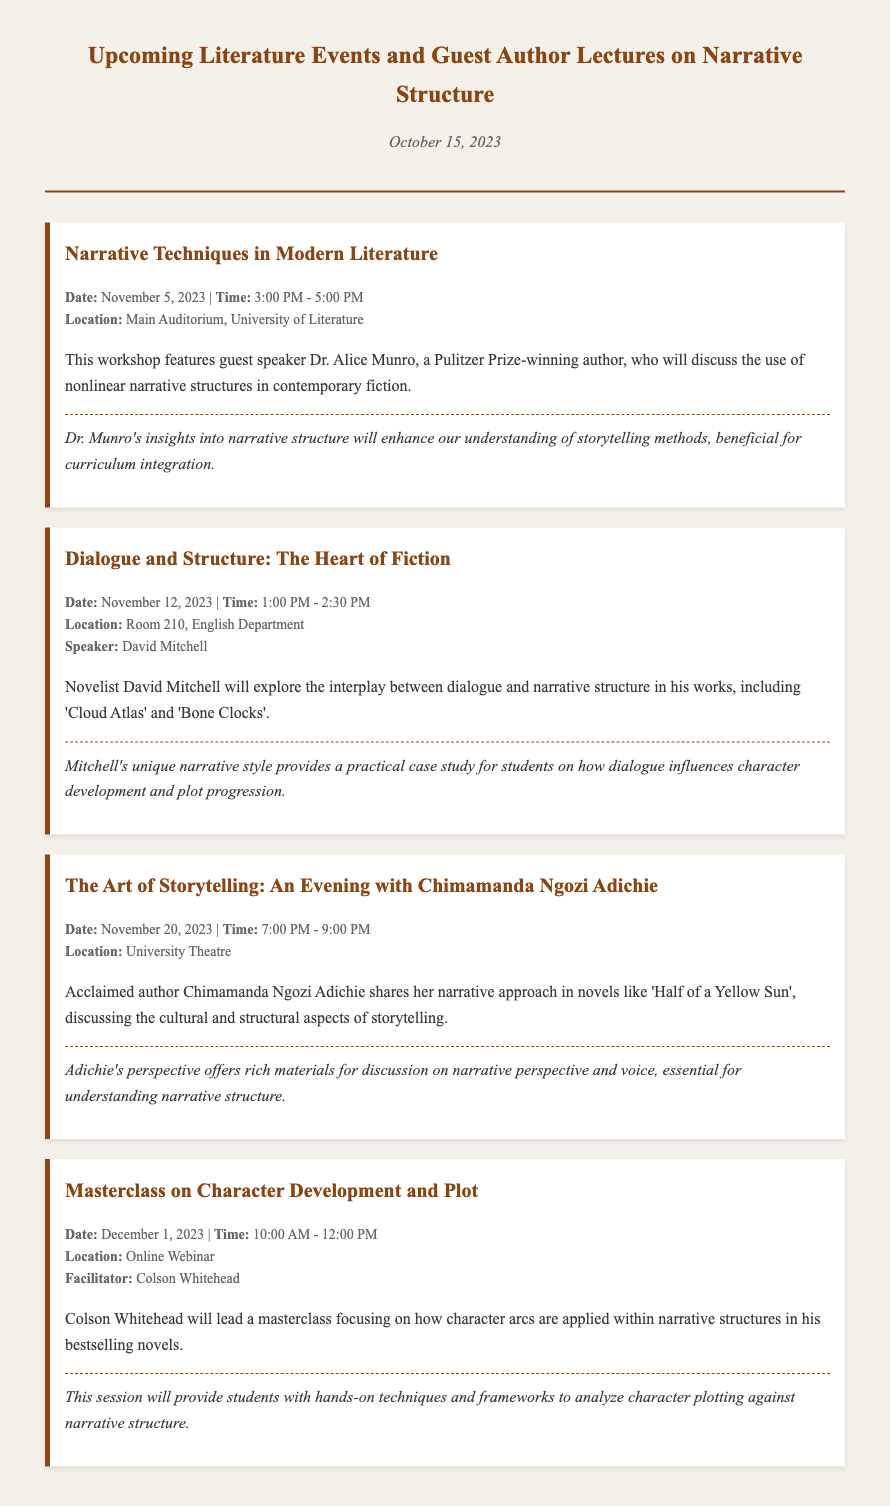What is the date of the first event? The first event listed is "Narrative Techniques in Modern Literature," which takes place on November 5, 2023.
Answer: November 5, 2023 Who is the guest speaker for the November 12 event? The speaker for the November 12 event "Dialogue and Structure: The Heart of Fiction" is David Mitchell.
Answer: David Mitchell What is the location of the November 20 event? The event on November 20 titled "The Art of Storytelling" is held at the University Theatre.
Answer: University Theatre Which author will discuss nonlinear narrative structures? Dr. Alice Munro will discuss nonlinear narrative structures at the event on November 5.
Answer: Dr. Alice Munro What is the focus of Colson Whitehead's masterclass? Colson Whitehead's masterclass focuses on how character arcs are applied within narrative structures.
Answer: Character arcs What thematic aspect does Chimamanda Ngozi Adichie emphasize in her lecture? Adichie discusses the cultural and structural aspects of storytelling in her lecture.
Answer: Cultural and structural aspects What time does the November 12 event start? The "Dialogue and Structure" event starts at 1:00 PM.
Answer: 1:00 PM How will Dr. Munro's insights be beneficial for students? Dr. Munro's insights will enhance understanding of storytelling methods, useful for curriculum integration.
Answer: Curriculum integration 